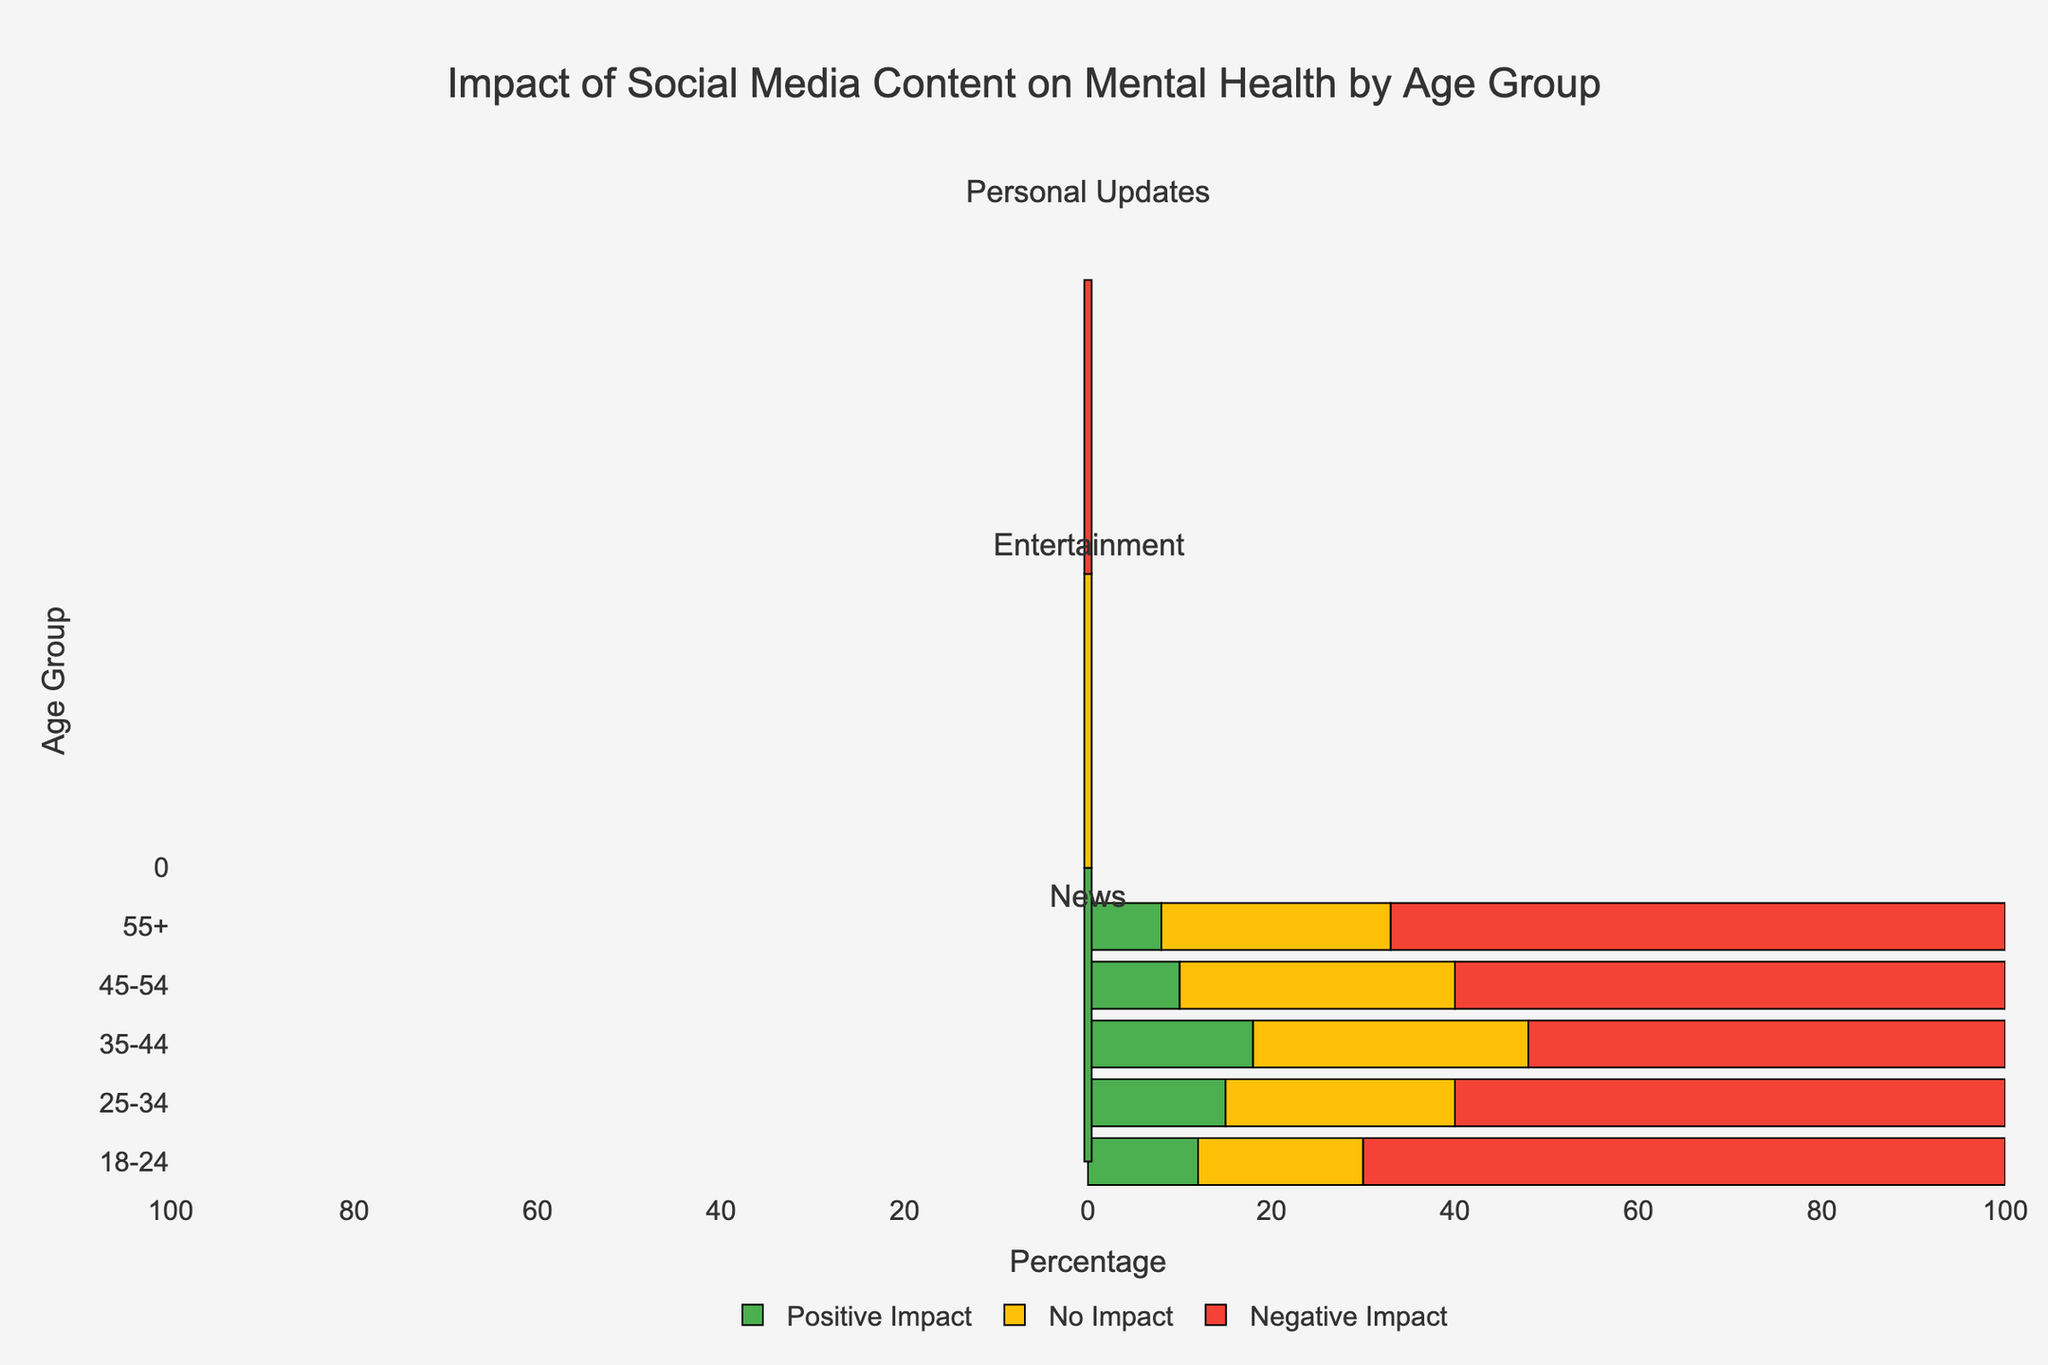Which age group reports the highest negative impact from News content? By examining the lengths of the bars representing the negative impact across different age groups for the News content, the longest bar corresponds to the 18-24 age group.
Answer: 18-24 Which content type has the lowest positive impact in the 55+ age group? By comparing the lengths of the green bars (representing positive impact) for the 55+ age group across all content types, the News content type has the shortest green bar.
Answer: News What is the difference in negative impact between Personal Updates and Entertainment content for the 18-24 age group? The negative impact for Personal Updates in the 18-24 age group is 35, and for Entertainment content, it is 25. The difference is 35 - 25.
Answer: 10 Which age group has the most balanced impact (similar positive, no impact, and negative percentages) for Personal Updates? By comparing the lengths of bars representing positive, no impact, and negative impacts for Personal Updates across all age groups, the 18-24 age group has the most balanced proportions (25-40-35).
Answer: 18-24 How does the percentage of no impact from Entertainment content in the 25-34 age group compare to the 35-44 age group? For the 25-34 age group, the no impact percentage is 35, and for the 35-44 age group, it is 25. By comparing these values, 35 is greater than 25.
Answer: 35-44 (less) What is the sum of positive and no impact percentages for Entertainment content in the 45-54 age group? The positive impact percentage is 60, and the no impact percentage is 25. Adding these together gives 60 + 25.
Answer: 85 Which content type shows the highest no impact value for Personal Updates in any age group? By examining the lengths of the yellow bars (representing no impact) for Personal Updates across all age groups, the longest bar is for the 55+ age group with a value of 50.
Answer: 55+ What is the positive impact percentage for News content in the 35-44 age group? By looking at the length of the green bar representing positive impact for News content in the 35-44 age group, the value is 18.
Answer: 18 